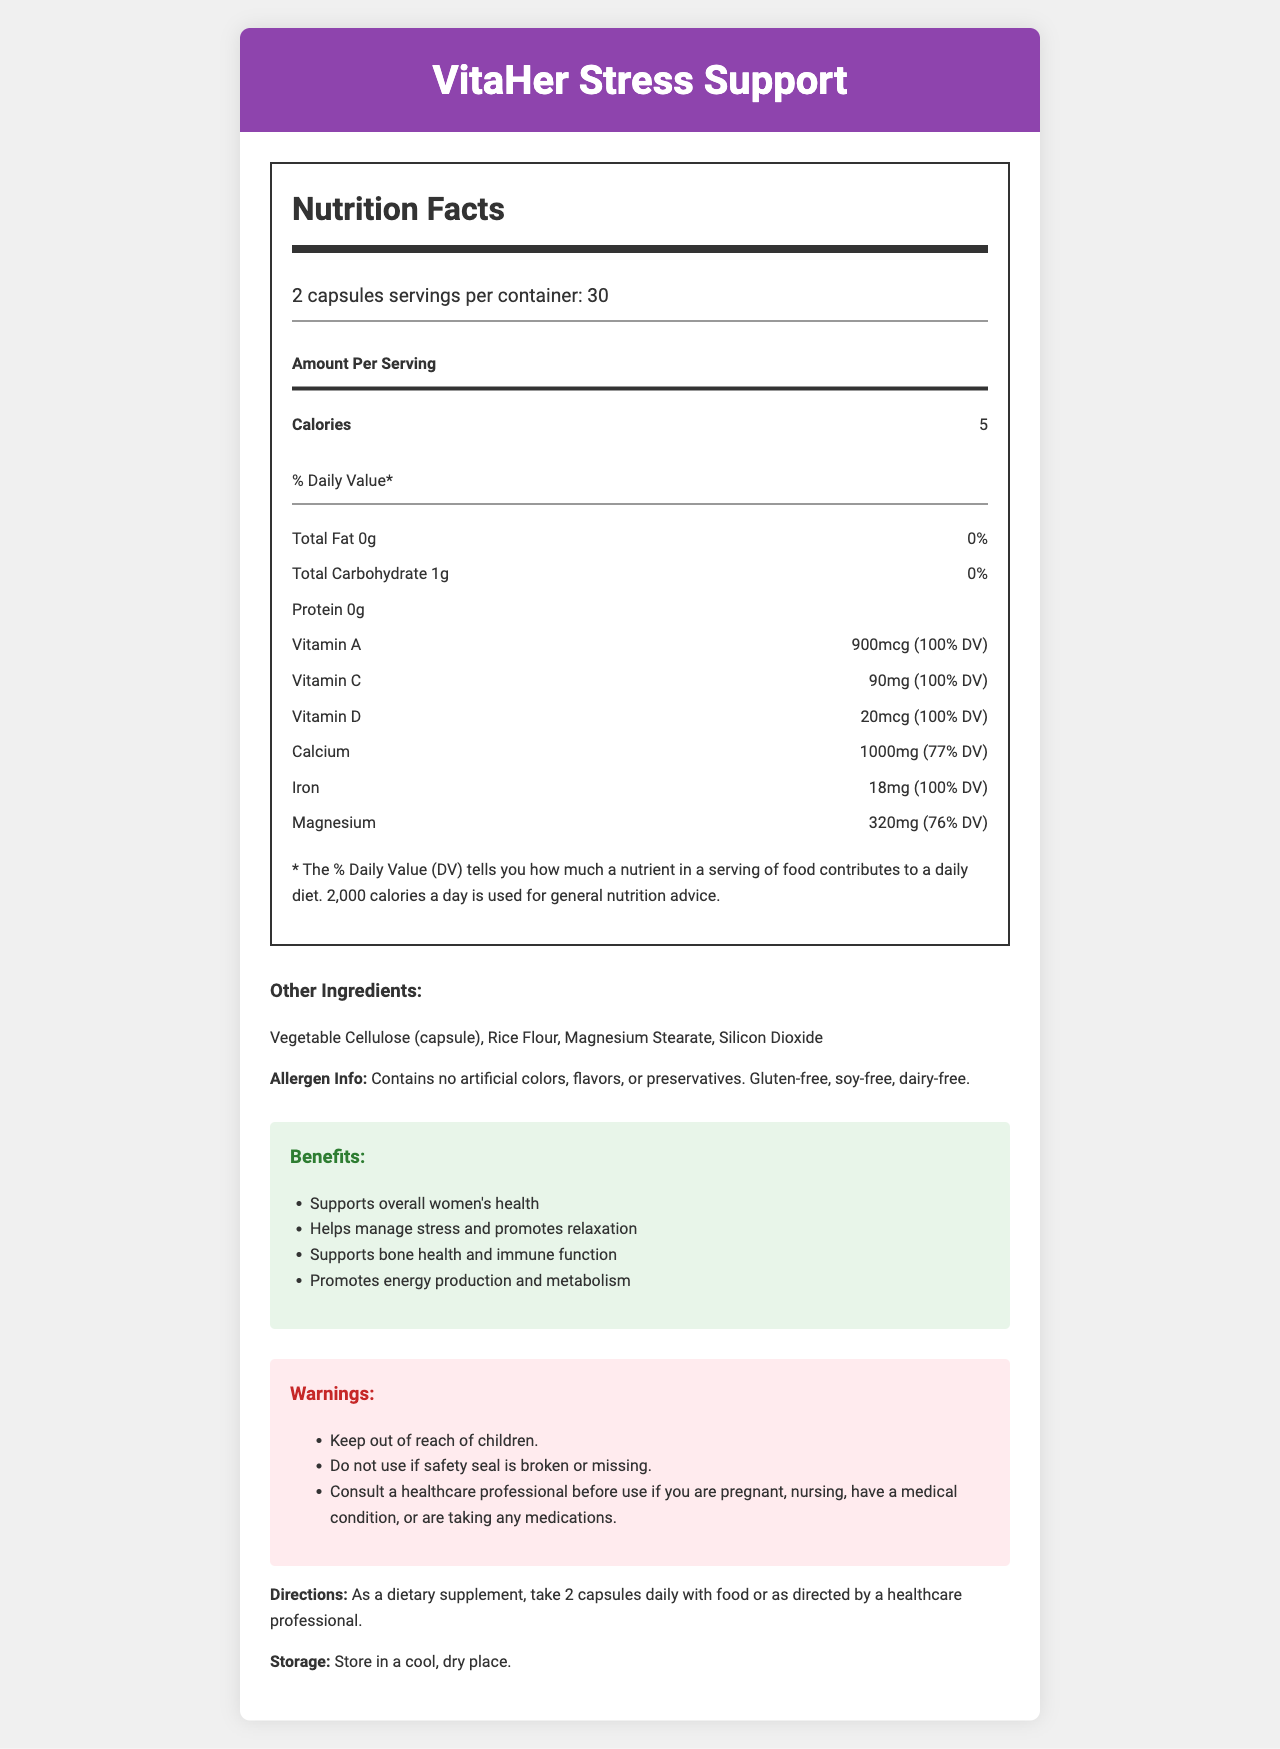what is the serving size for VitaHer Stress Support? The document states that the serving size is 2 capsules.
Answer: 2 capsules how many servings per container are there? According to the document, there are 30 servings per container.
Answer: 30 what is the calorie content per serving? The document lists the calorie content as 5 calories per serving.
Answer: 5 calories what are the main ingredients in the Stress Support Blend? The Stress Support Blend is specified to contain these ingredients.
Answer: Ashwagandha Root Extract, L-Theanine, Rhodiola Rosea Root Extract, Lemon Balm Leaf Extract are there any allergens in the product? The Allergen Info section states that the product contains no artificial colors, flavors, or preservatives and is gluten-free, soy-free, and dairy-free.
Answer: No what percentage of the Daily Value (DV) does vitamin A provide? The document shows that vitamin A provides 100% of the Daily Value.
Answer: 100% what are the warnings provided for the product? These warnings are listed under the Warnings section.
Answer: Keep out of reach of children. Do not use if safety seal is broken or missing. Consult a healthcare professional before use if you are pregnant, nursing, have a medical condition, or are taking any medications. which vitamin is provided at 120mcg in each serving? The document indicates that each serving contains 120mcg of vitamin K.
Answer: Vitamin K what is the main purpose of VitaHer Stress Support? These benefits are listed in the Benefits section.
Answer: Supports overall women's health, helps manage stress and promotes relaxation, supports bone health and immune function, promotes energy production and metabolism what are the storage instructions for this supplement? The storage instructions specify to store the product in a cool, dry place.
Answer: Store in a cool, dry place. what should you do if the safety seal is broken or missing? A. Take as directed B. Discard immediately C. Consult a healthcare professional D. Return to the store It is advised under the Warnings section to not use the product if the safety seal is broken or missing.
Answer: B. Discard immediately what is the magnesium content per serving? A. 320mg B. 1000mg C. 18mg D. 55mcg The document states that the magnesium content per serving is 320mg.
Answer: A. 320mg is this product recommended for children? The warning advises to keep the product out of reach of children, implying it is not recommended for them.
Answer: No briefly summarize the main idea of this document. The document primarily offers comprehensive details about the supplement designed for women's health, including its nutritional composition, intended benefits, and safety guidelines.
Answer: The document provides a detailed Nutrition Facts Label for the VitaHer Stress Support vitamin supplement, aimed at supporting women's health and stress management. It includes information on serving size, nutritional content, ingredients, benefits, warnings, and storage instructions. what is the source of the code used to generate the document? The visual document does not provide any information regarding the source of the code used to generate it.
Answer: Not enough information 